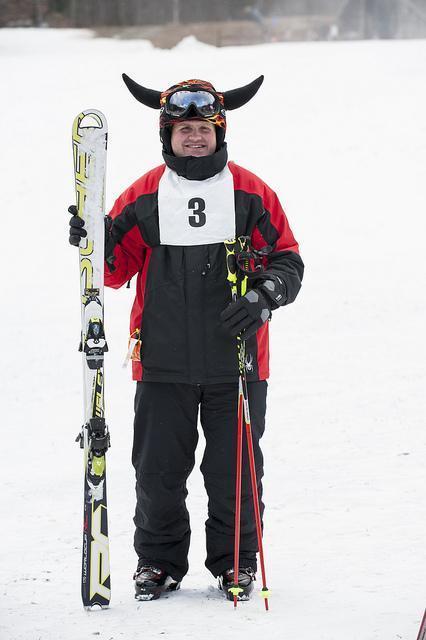How many black cups are there?
Give a very brief answer. 0. 